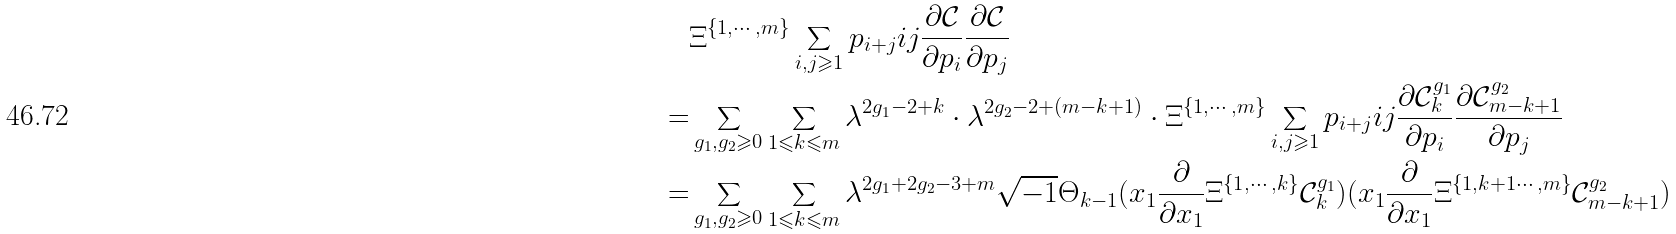Convert formula to latex. <formula><loc_0><loc_0><loc_500><loc_500>& \Xi ^ { \{ 1 , \cdots , m \} } \sum _ { i , j \geqslant 1 } p _ { i + j } i j \frac { \partial \mathcal { C } } { \partial p _ { i } } \frac { \partial \mathcal { C } } { \partial p _ { j } } \\ = & \sum _ { g _ { 1 } , g _ { 2 } \geqslant 0 } \sum _ { 1 \leqslant k \leqslant m } \lambda ^ { 2 g _ { 1 } - 2 + k } \cdot \lambda ^ { 2 g _ { 2 } - 2 + ( m - k + 1 ) } \cdot \Xi ^ { \{ 1 , \cdots , m \} } \sum _ { i , j \geqslant 1 } p _ { i + j } i j \frac { \partial \mathcal { C } _ { k } ^ { g _ { 1 } } } { \partial p _ { i } } \frac { \partial \mathcal { C } _ { m - k + 1 } ^ { g _ { 2 } } } { \partial p _ { j } } \\ = & \sum _ { g _ { 1 } , g _ { 2 } \geqslant 0 } \sum _ { 1 \leqslant k \leqslant m } \lambda ^ { 2 g _ { 1 } + 2 g _ { 2 } - 3 + m } \sqrt { - 1 } \Theta _ { k - 1 } ( x _ { 1 } \frac { \partial } { \partial x _ { 1 } } \Xi ^ { \{ 1 , \cdots , k \} } \mathcal { C } _ { k } ^ { g _ { 1 } } ) ( x _ { 1 } \frac { \partial } { \partial x _ { 1 } } \Xi ^ { \{ 1 , k + 1 \cdots , m \} } \mathcal { C } _ { m - k + 1 } ^ { g _ { 2 } } )</formula> 